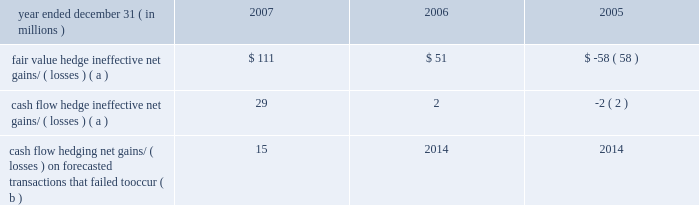Jpmorgan chase & co .
/ 2007 annual report 169 for qualifying fair value hedges , all changes in the fair value of the derivative and in the fair value of the hedged item for the risk being hedged are recognized in earnings .
If the hedge relationship is termi- nated , then the fair value adjustment to the hedged item continues to be reported as part of the basis of the item and continues to be amor- tized to earnings as a yield adjustment .
For qualifying cash flow hedges , the effective portion of the change in the fair value of the derivative is recorded in other comprehensive income and recognized in the consolidated statement of income when the hedged cash flows affect earnings .
The ineffective portions of cash flow hedges are immediately recognized in earnings .
If the hedge relationship is terminated , then the change in fair value of the derivative recorded in other comprehensive income is recognized when the cash flows that were hedged occur , con- sistent with the original hedge strategy .
For hedge relationships discon- tinued because the forecasted transaction is not expected to occur according to the original strategy , any related derivative amounts recorded in other comprehensive income are immediately recognized in earnings .
For qualifying net investment hedges , changes in the fair value of the derivative or the revaluation of the foreign currency 2013denominated debt instrument are recorded in the translation adjustments account within other comprehensive income .
Jpmorgan chase 2019s fair value hedges primarily include hedges of fixed- rate long-term debt , warehouse loans , afs securities , msrs and gold inventory .
Interest rate swaps are the most common type of derivative contract used to modify exposure to interest rate risk , converting fixed-rate assets and liabilities to a floating-rate .
Prior to the adoption of sfas 156 , interest rate options , swaptions and forwards were also used in combination with interest rate swaps to hedge the fair value of the firm 2019s msrs in sfas 133 hedge relationships .
For a further discus- sion of msr risk management activities , see note 18 on pages 154 2013156 of this annual report .
All amounts have been included in earnings consistent with the classification of the hedged item , primarily net interest income for long-term debt and afs securities ; mortgage fees and related income for msrs , other income for warehouse loans ; and principal transactions for gold inventory .
The firm did not recog- nize any gains or losses during 2007 , 2006 or 2005 on firm commit- ments that no longer qualify as fair value hedges .
Jpmorgan chase also enters into derivative contracts to hedge expo- sure to variability in cash flows from floating-rate financial instruments and forecasted transactions , primarily the rollover of short-term assets and liabilities , and foreign currency 2013denominated revenue and expense .
Interest rate swaps , futures and forward contracts are the most common instruments used to reduce the impact of interest rate and foreign exchange rate changes on future earnings .
All amounts affecting earnings have been recognized consistent with the classifica- tion of the hedged item , primarily net interest income .
The firm uses forward foreign exchange contracts and foreign curren- cy 2013denominated debt instruments to protect the value of net invest- ments in subsidiaries , the functional currency of which is not the u.s .
Dollar .
The portion of the hedging instruments excluded from the assessment of hedge effectiveness ( forward points ) is recorded in net interest income .
The table presents derivative instrument hedging-related activities for the periods indicated. .
Fair value hedge ineffective net gains/ ( losses ) ( a ) $ 111 $ 51 $ ( 58 ) cash flow hedge ineffective net gains/ ( losses ) ( a ) 29 2 ( 2 ) cash flow hedging net gains/ ( losses ) on forecasted transactions that failed to occur ( b ) 15 2014 2014 ( a ) includes ineffectiveness and the components of hedging instruments that have been excluded from the assessment of hedge effectiveness .
( b ) during the second half of 2007 , the firm did not issue short-term fixed rate canadian dollar denominated notes due to the weak credit market for canadian short-term over the next 12 months , it is expected that $ 263 million ( after-tax ) of net losses recorded in other comprehensive income at december 31 , 2007 , will be recognized in earnings .
The maximum length of time over which forecasted transactions are hedged is 10 years , and such transactions primarily relate to core lending and borrowing activities .
Jpmorgan chase does not seek to apply hedge accounting to all of the firm 2019s economic hedges .
For example , the firm does not apply hedge accounting to standard credit derivatives used to manage the credit risk of loans and commitments because of the difficulties in qualifying such contracts as hedges under sfas 133 .
Similarly , the firm does not apply hedge accounting to certain interest rate deriva- tives used as economic hedges. .
In 2007 what was the ratio of the fair value hedge ineffective net gains/ ( losses ) to the cash flow hedge ineffective net gains/ ( losses ) ( a )? 
Computations: (111 / 29)
Answer: 3.82759. 